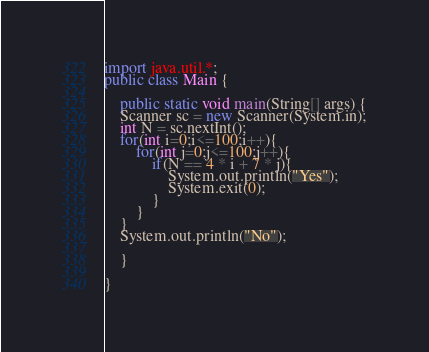Convert code to text. <code><loc_0><loc_0><loc_500><loc_500><_Java_>import java.util.*;
public class Main {

	public static void main(String[] args) {
	Scanner sc = new Scanner(System.in);
	int N = sc.nextInt();
	for(int i=0;i<=100;i++){
		for(int j=0;j<=100;j++){
			if(N == 4 * i + 7 * j){
				System.out.println("Yes");
				System.exit(0);
			}
		}
	}
	System.out.println("No");

	}

}
</code> 